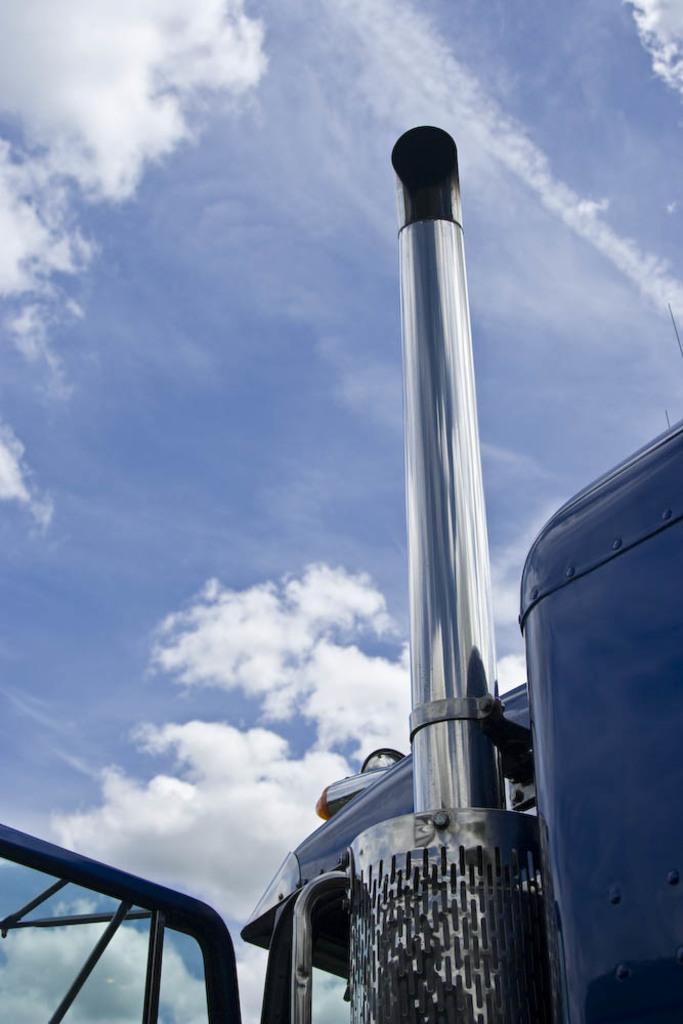How would you summarize this image in a sentence or two? In this image, on the right side, we can see one edge of a vehicle. In the middle of the image, we can see a metal instrument. On the left side, we can also see the metal grill of a vehicle. In the background, we can see a sky which is a bit cloudy. 